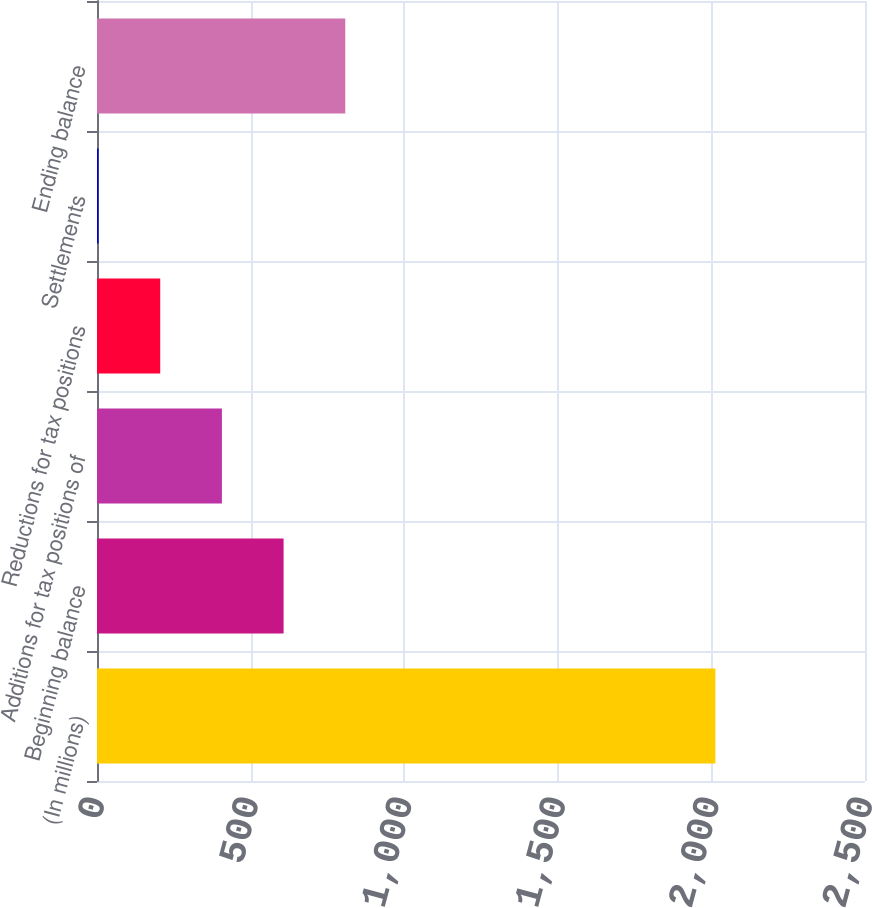Convert chart to OTSL. <chart><loc_0><loc_0><loc_500><loc_500><bar_chart><fcel>(In millions)<fcel>Beginning balance<fcel>Additions for tax positions of<fcel>Reductions for tax positions<fcel>Settlements<fcel>Ending balance<nl><fcel>2013<fcel>607.4<fcel>406.6<fcel>205.8<fcel>5<fcel>808.2<nl></chart> 